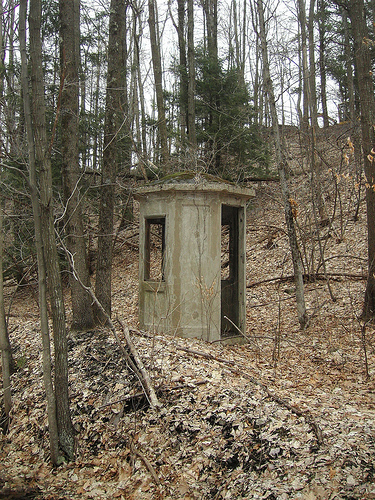<image>
Is the tree to the right of the ground? No. The tree is not to the right of the ground. The horizontal positioning shows a different relationship. Is the tree next to the ground? No. The tree is not positioned next to the ground. They are located in different areas of the scene. Is the tree above the building? Yes. The tree is positioned above the building in the vertical space, higher up in the scene. 